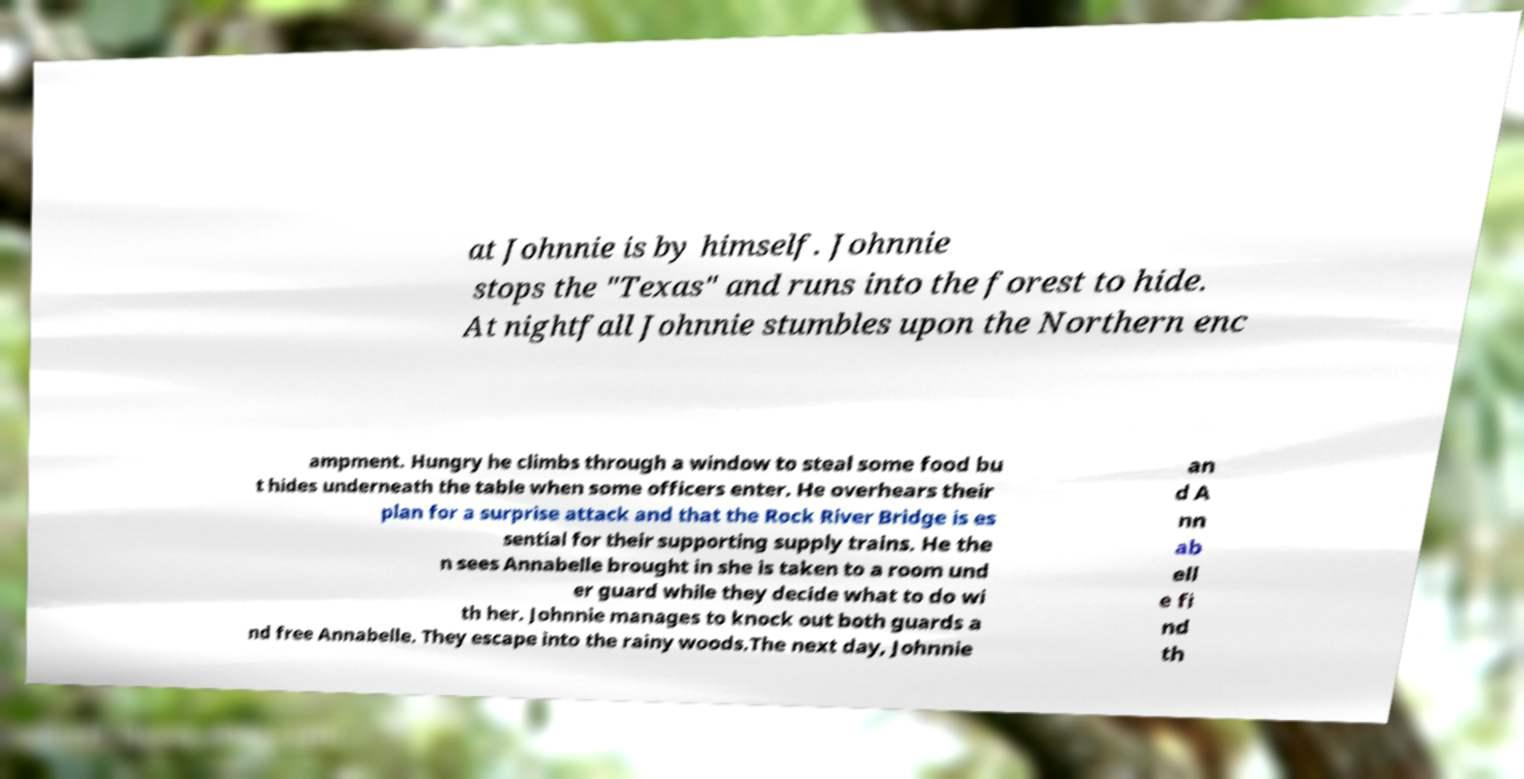What messages or text are displayed in this image? I need them in a readable, typed format. at Johnnie is by himself. Johnnie stops the "Texas" and runs into the forest to hide. At nightfall Johnnie stumbles upon the Northern enc ampment. Hungry he climbs through a window to steal some food bu t hides underneath the table when some officers enter. He overhears their plan for a surprise attack and that the Rock River Bridge is es sential for their supporting supply trains. He the n sees Annabelle brought in she is taken to a room und er guard while they decide what to do wi th her. Johnnie manages to knock out both guards a nd free Annabelle. They escape into the rainy woods.The next day, Johnnie an d A nn ab ell e fi nd th 